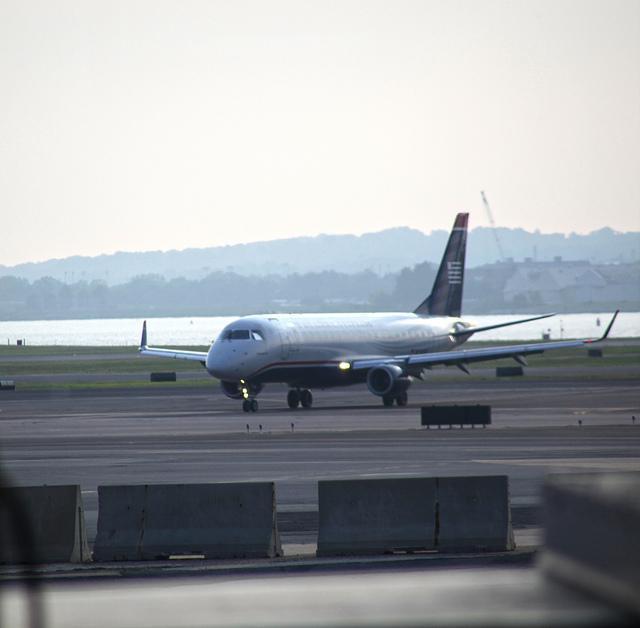How many planes are in the photo?
Give a very brief answer. 1. 